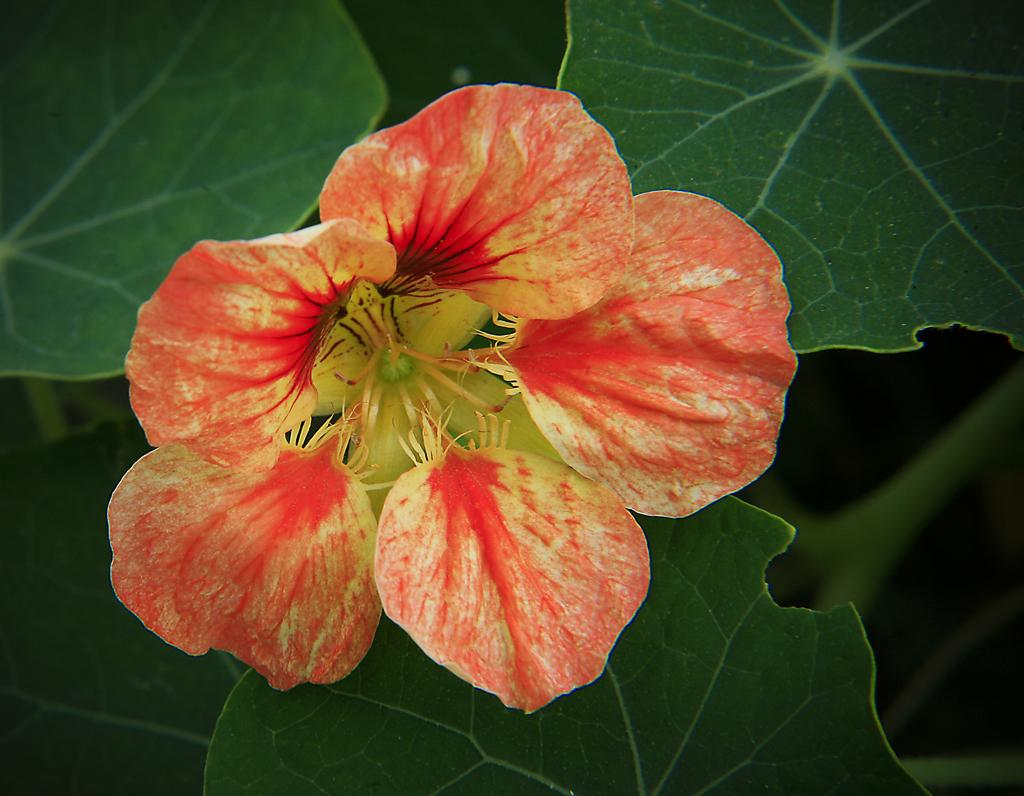What is the main subject of the image? There is a beautiful flower in the image. What else can be seen in the image besides the flower? There are leaves of a plant in the image. What type of animal can be seen holding a gun in the image? There is no animal or gun present in the image; it features a beautiful flower and leaves of a plant. 